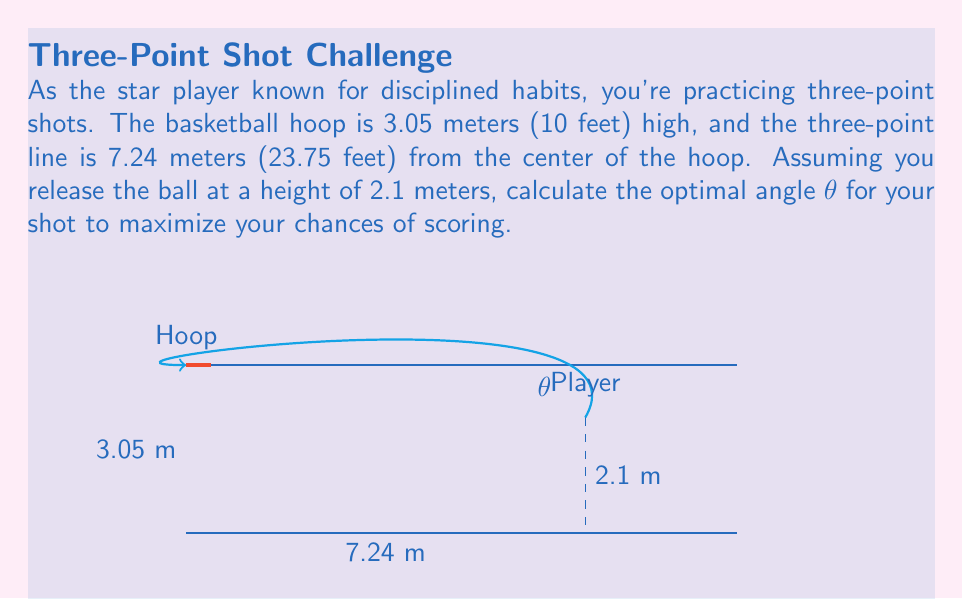Could you help me with this problem? Let's approach this step-by-step:

1) We can treat this as a projectile motion problem in a coordinate system where the hoop is at (0, 3.05) and the player is at (7.24, 2.1).

2) The equation for the trajectory of the ball is:

   $$y = \tan(\theta)x - \frac{g}{2v_0^2\cos^2(\theta)}x^2 + 2.1$$

   Where $g$ is the acceleration due to gravity (9.8 m/s²), $v_0$ is the initial velocity, and $\theta$ is the angle of release.

3) For the ball to go through the hoop, we need:

   $$3.05 = \tan(\theta)(0) - \frac{g}{2v_0^2\cos^2(\theta)}(0)^2 + 2.1$$

   $$3.05 = 2.1 + 7.24\tan(\theta) - \frac{9.8(7.24)^2}{2v_0^2\cos^2(\theta)}$$

4) The optimal angle is the one that requires the minimum initial velocity. We can find this by differentiating the equation with respect to $\theta$ and setting it to zero.

5) After differentiation and simplification, we get:

   $$\tan(\theta) = \frac{7.24}{0.95} \approx 7.62$$

6) Taking the inverse tangent:

   $$\theta = \arctan(7.62) \approx 1.44 \text{ radians} \approx 82.5°$$

This angle maximizes the chances of scoring by minimizing the required initial velocity.
Answer: $82.5°$ 